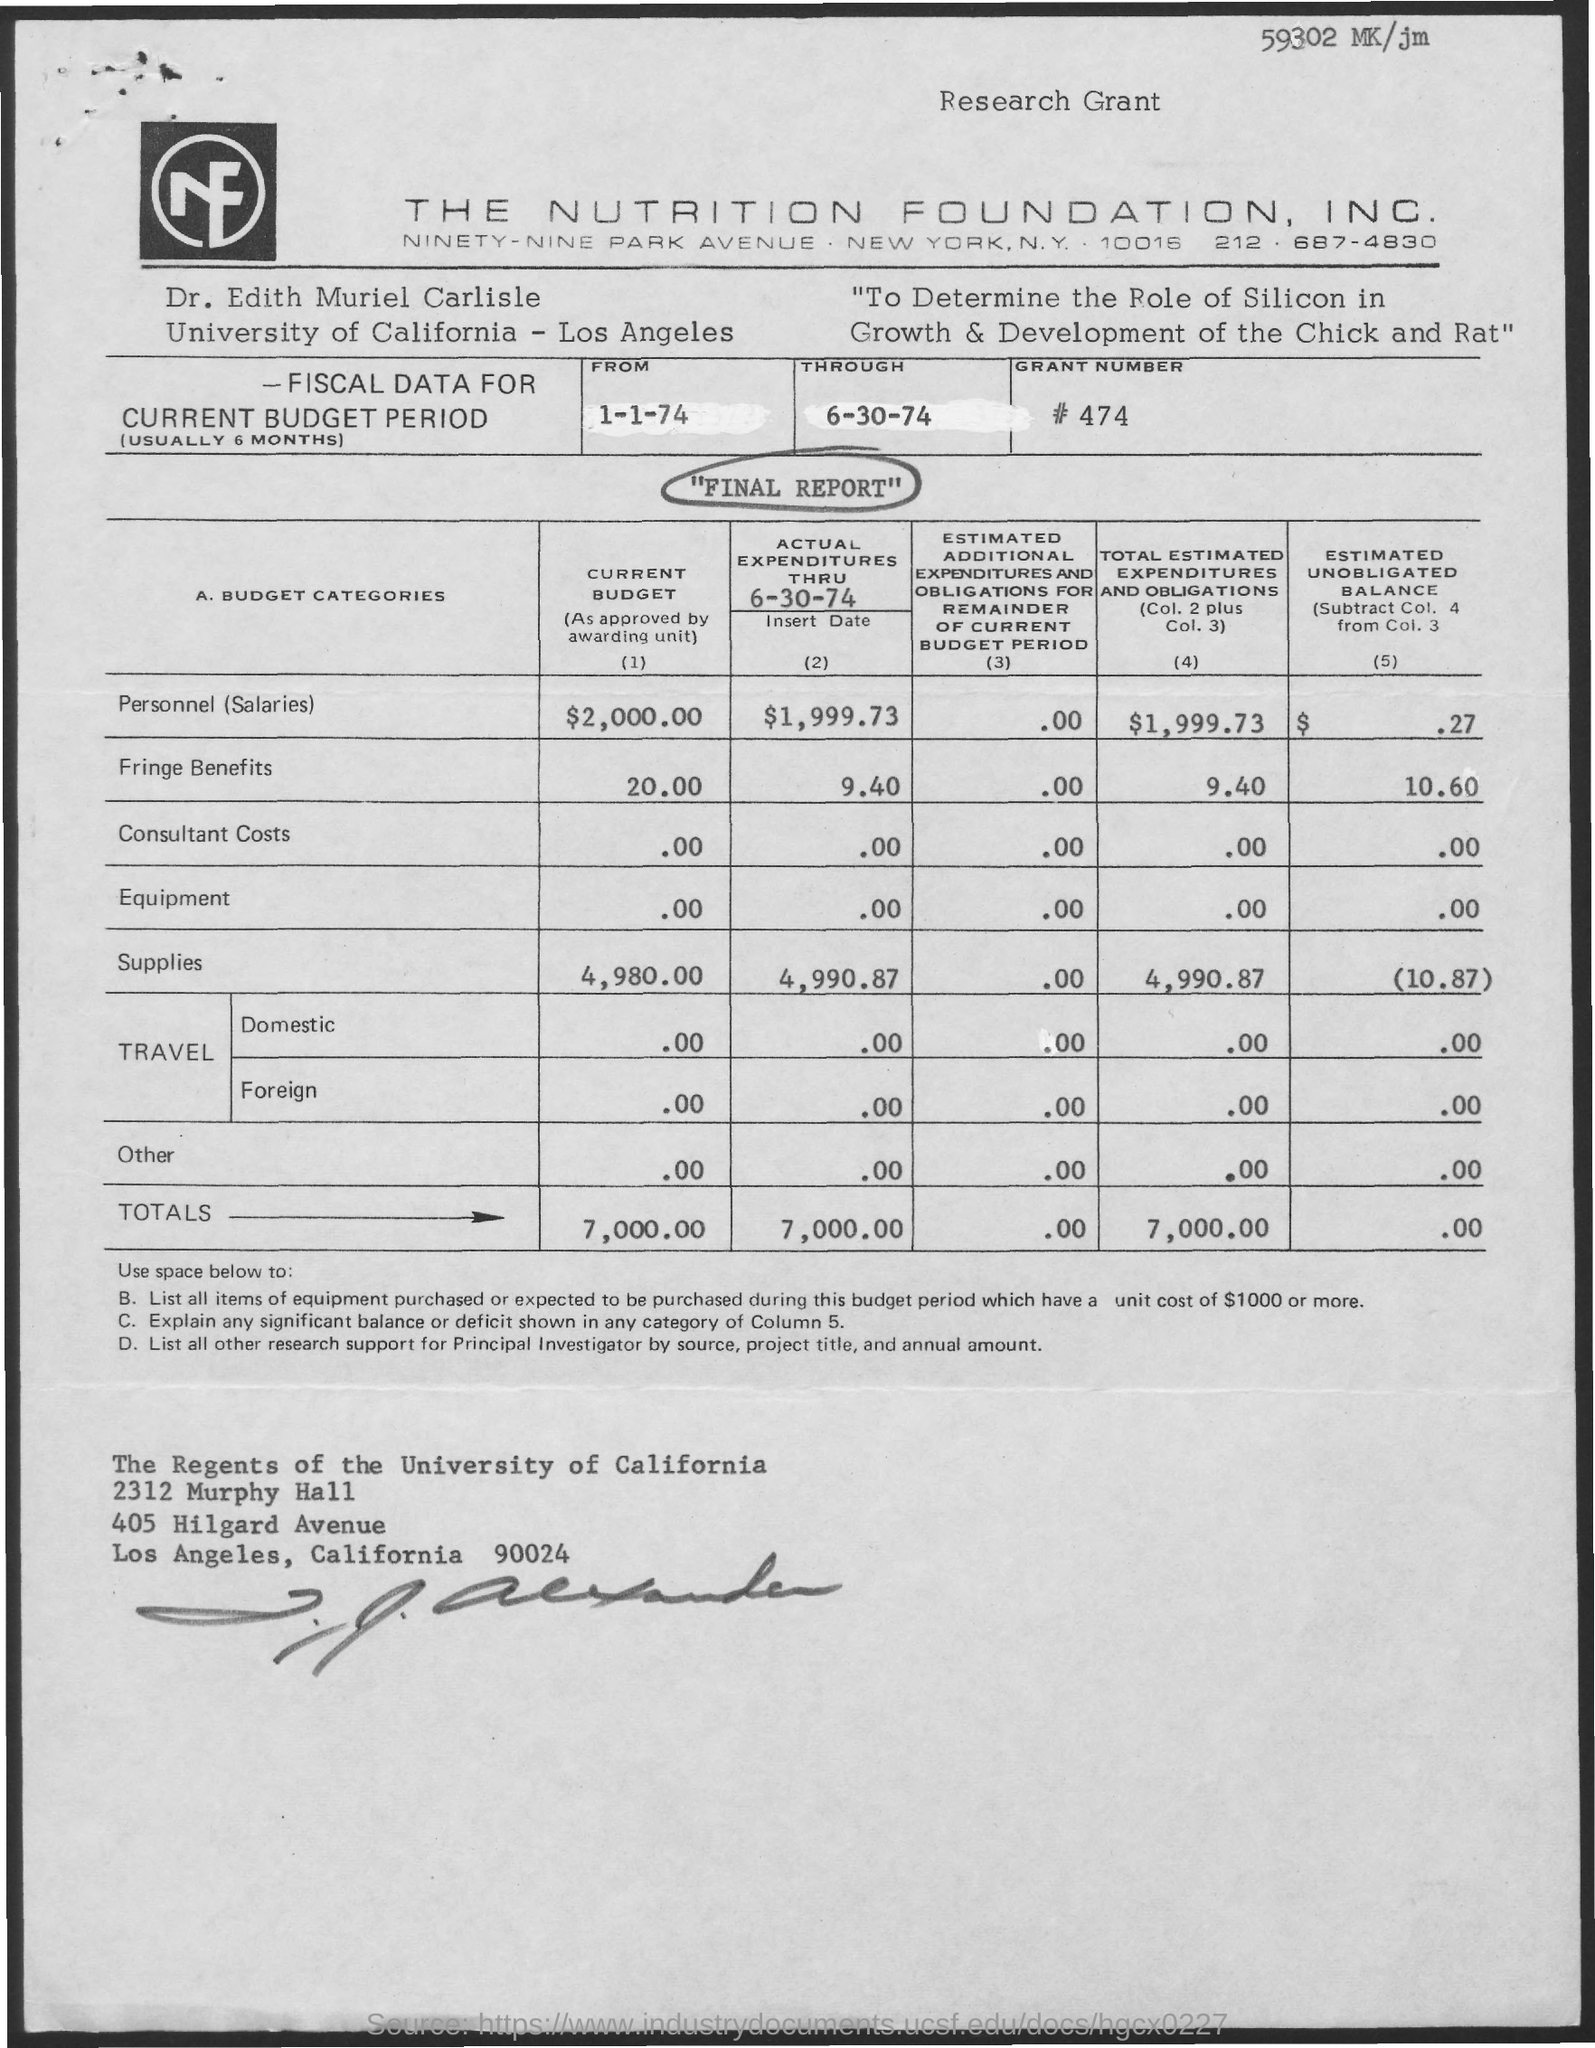Identify some key points in this picture. The total current budget is 7000.00. 